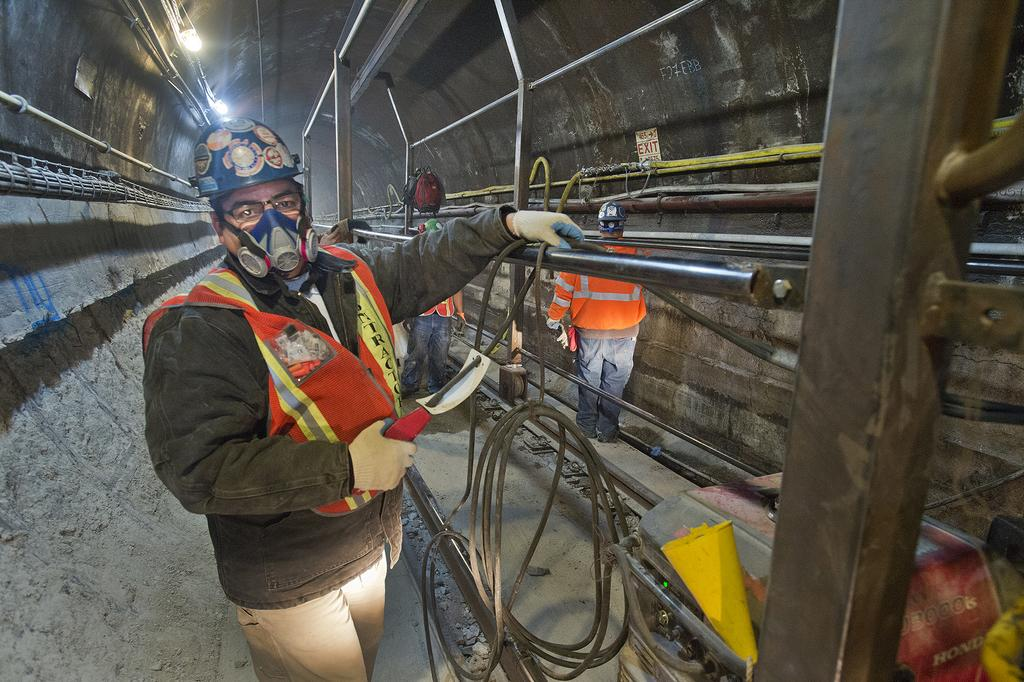What type of location is shown in the image? The image depicts an underground location. What structures can be seen in the image? There are poles in the image. Who or what is present in the image? There are people in the image. What else can be seen in the image besides people and poles? There are machines in the image. Can you describe any other objects in the image? There are other unspecified objects in the image. What type of pickle is being used to lubricate the machines in the image? There is no pickle present in the image, and therefore no such activity can be observed. 